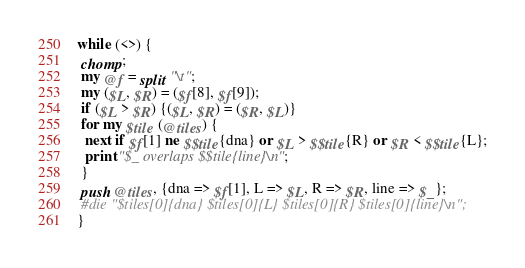<code> <loc_0><loc_0><loc_500><loc_500><_Perl_>while (<>) {
 chomp;
 my @f = split "\t";
 my ($L, $R) = ($f[8], $f[9]);
 if ($L > $R) {($L, $R) = ($R, $L)}
 for my $tile (@tiles) {
  next if $f[1] ne $$tile{dna} or $L > $$tile{R} or $R < $$tile{L};
  print "$_ overlaps $$tile{line}\n";
 }
 push @tiles, {dna => $f[1], L => $L, R => $R, line => $_};
 #die "$tiles[0]{dna} $tiles[0]{L} $tiles[0]{R} $tiles[0]{line}\n";
}
</code> 